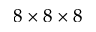Convert formula to latex. <formula><loc_0><loc_0><loc_500><loc_500>8 \times 8 \times 8</formula> 